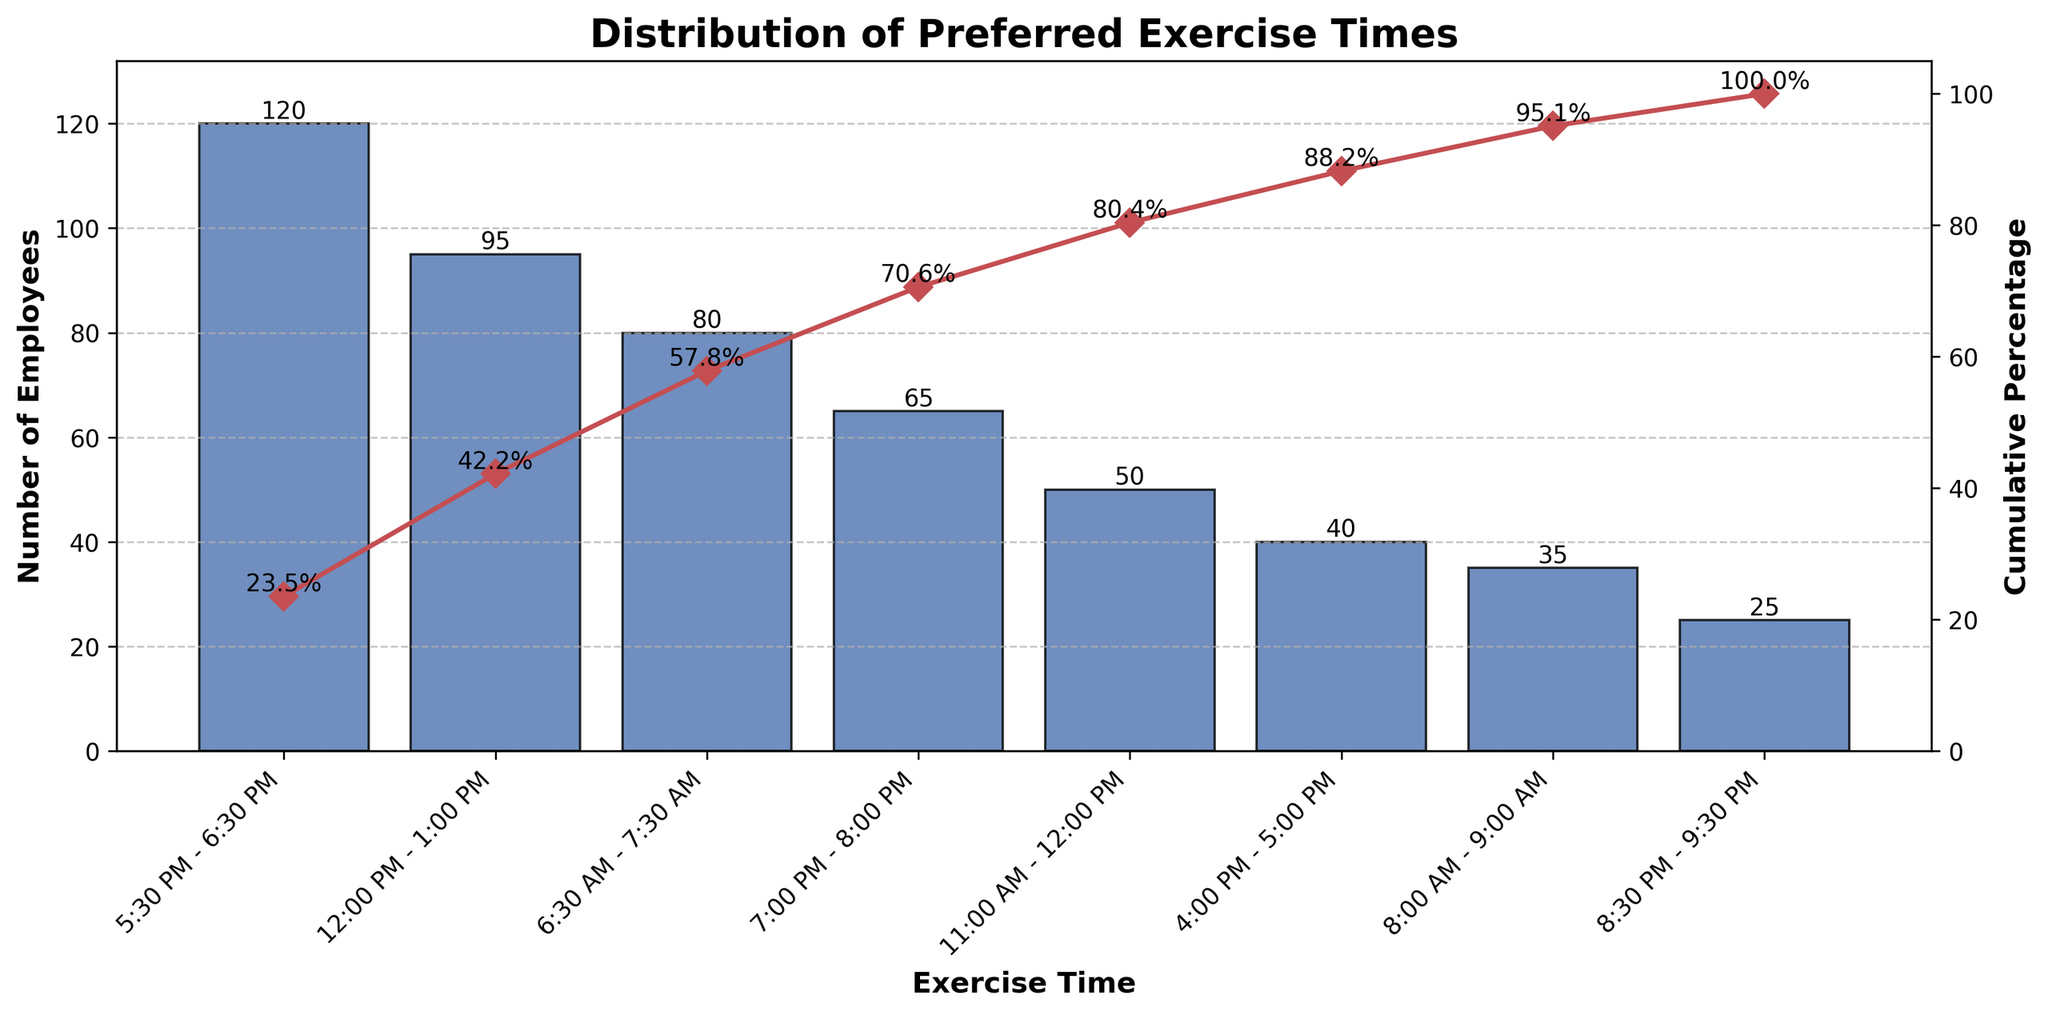Which exercise time had the highest number of employees? The bar with the highest height represents the most preferred exercise time. This occurs at the time with the label '5:30 PM - 6:30 PM'.
Answer: 5:30 PM - 6:30 PM What is the cumulative percentage of employees who prefer exercising between 5:30 PM - 6:30 PM and 12:00 PM - 1:00 PM combined? The cumulative percentage line tells us how many people prefer certain times cumulatively. At '12:00 PM - 1:00 PM', the cumulative percentage is 63.2%.
Answer: 63.2% Which exercise time had the lowest number of employees? The bar with the lowest height represents the least preferred exercise time. This occurs at the time with the label '8:30 PM - 9:30 PM'.
Answer: 8:30 PM - 9:30 PM How many fewer employees prefer exercising at 8:00 AM - 9:00 AM compared to 6:30 AM - 7:30 AM? Look at the bars for '8:00 AM - 9:00 AM' and '6:30 AM - 7:30 AM'. The heights are 35 and 80 respectively, the difference is 80 - 35.
Answer: 45 What percentage of employees prefer times before noon? Add the number of employees for slots '6:30 AM - 7:30 AM', '8:00 AM - 9:00 AM', '11:00 AM - 12:00 PM', then divide by the total number of employees and multiply by 100. The calculation is ((80 + 35 + 50) / 510) * 100.
Answer: 32.9% How many employees in total prefer evening exercise times (post 4:00 PM)? Add the number of employees for slots '5:30 PM - 6:30 PM', '7:00 PM - 8:00 PM', and '8:30 PM - 9:30 PM'. The total is 120 + 65 + 25.
Answer: 210 What is the cumulative percentage at the 4th most popular exercise time? Identify the 4th highest bar, which corresponds to '7:00 PM - 8:00 PM'. The cumulative percentage for this time slot is visible in the plot, and it is 70.6%.
Answer: 70.6% How many timeslots are included in the Pareto chart? Count the number of labels on the x-axis which represent different exercise times. There are 8 labels.
Answer: 8 What is the median preferred exercise time based on the number of employees? Arrange the exercise times in descending order of preference and find the median. The times are: '5:30 PM - 6:30 PM', '12:00 PM - 1:00 PM', '6:30 AM - 7:30 AM', '7:00 PM - 8:00 PM', '11:00 AM - 12:00 PM', '4:00 PM - 5:00 PM', '8:00 AM - 9:00 AM', '8:30 PM - 9:30 PM'. The median times are '7:00 PM - 8:00 PM' and '11:00 AM - 12:00 PM', so the average of these times is the median.
Answer: 7:00 PM - 8:00 PM and 11:00 AM - 12:00 PM 